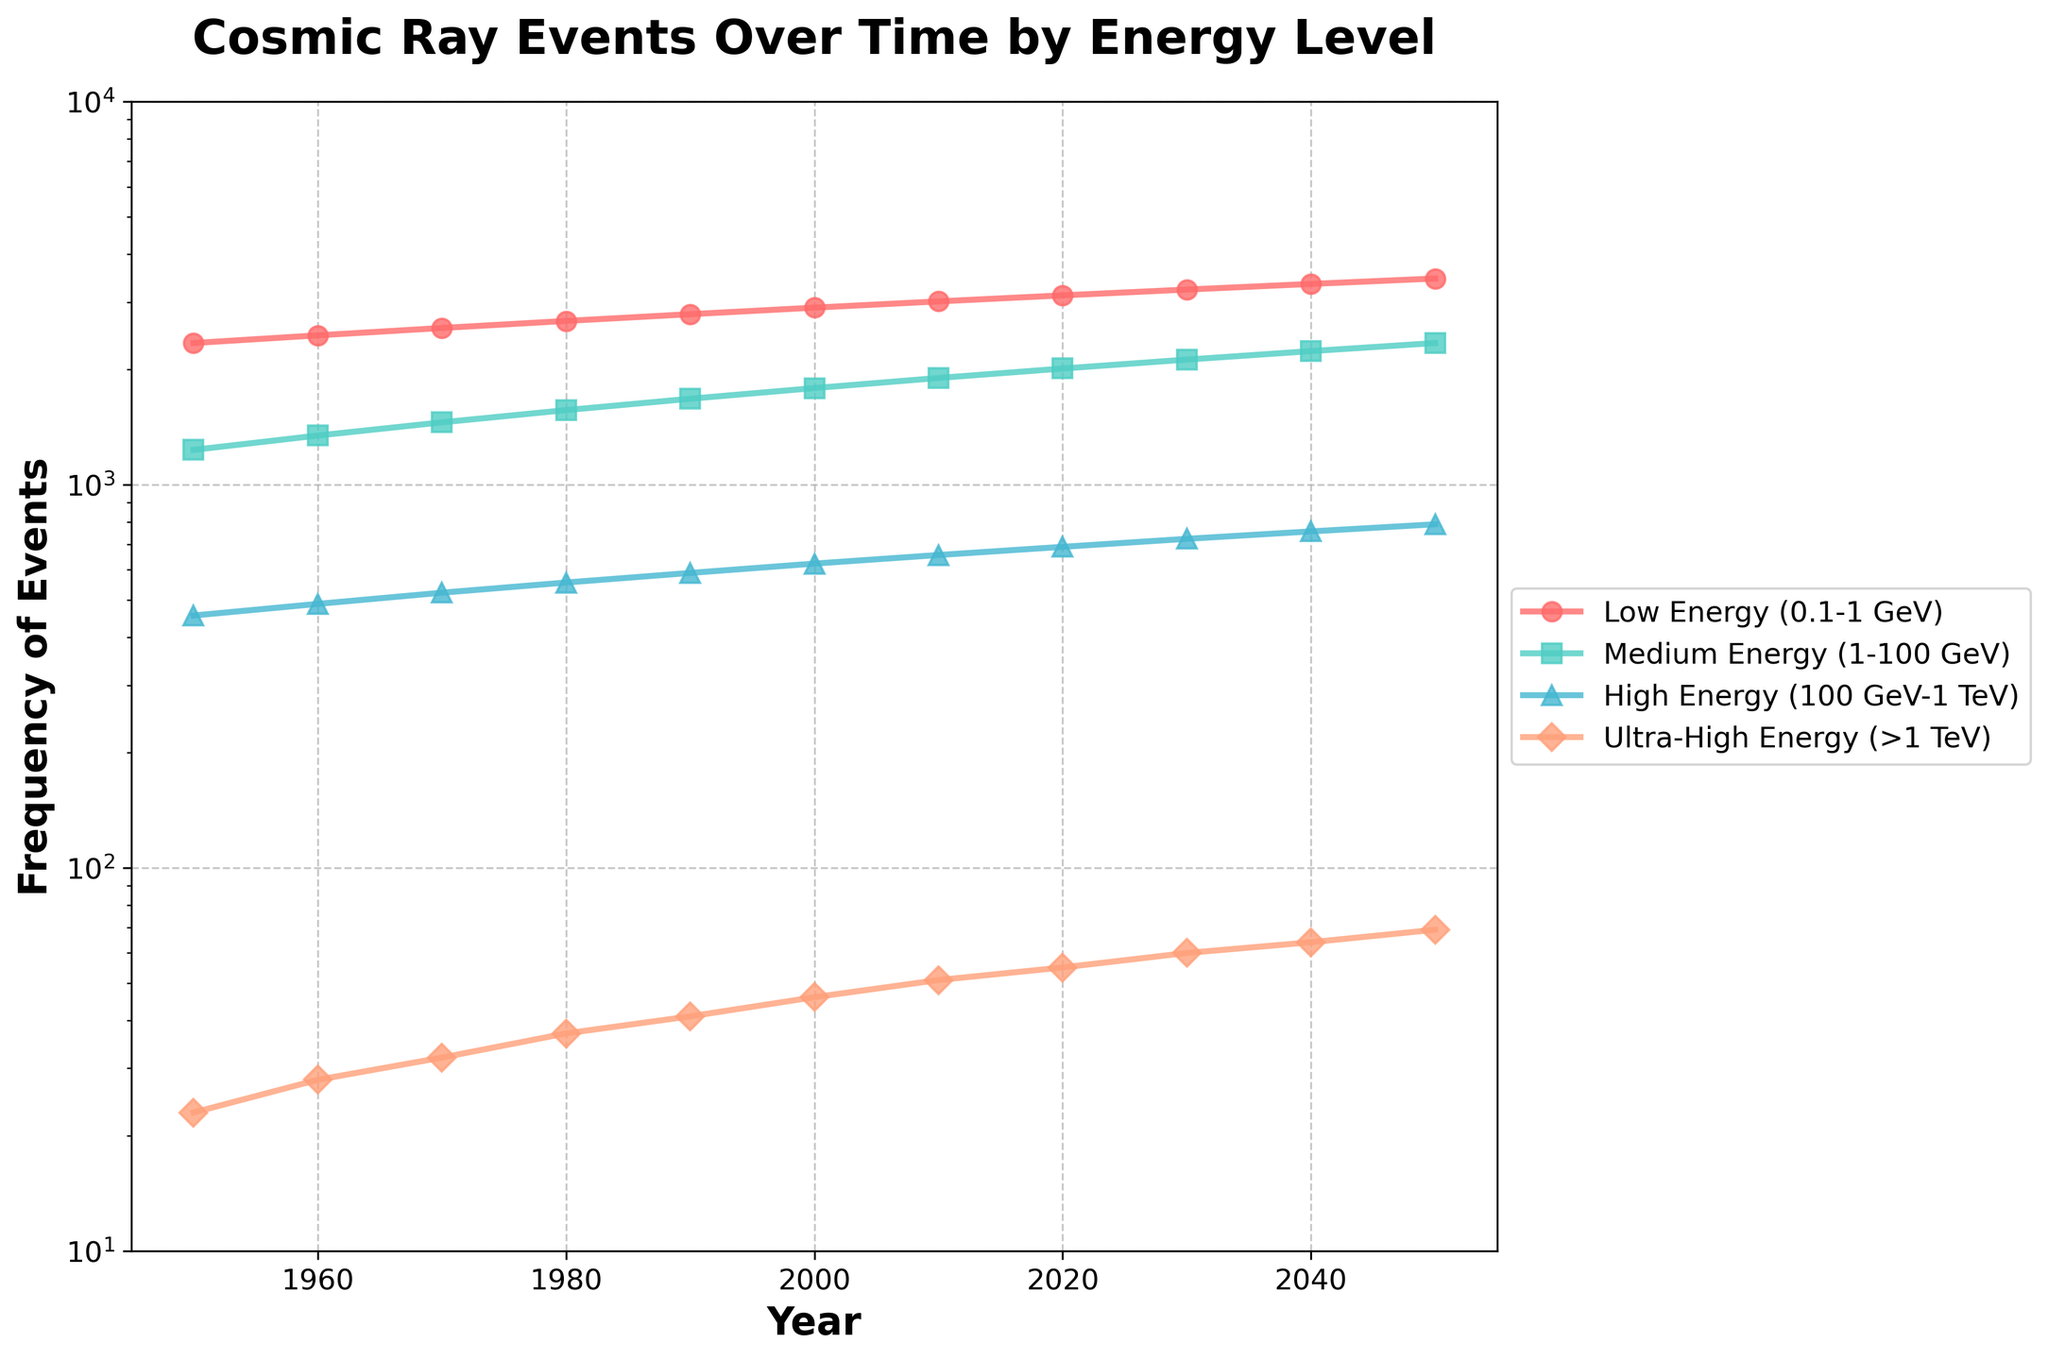What is the overall trend of Ultra-High Energy (>1 TeV) events from 1950 to 2050? To identify the trend, observe the line corresponding to Ultra-High Energy events. From 1950 to 2050, the frequency of events increases from 23 to 69, indicating an upward trend.
Answer: Upward trend In what year did Low Energy (0.1-1 GeV) events first exceed 3000? Look at the line representing Low Energy events. In 2010, the frequency of Low Energy events surpasses 3000 for the first time.
Answer: 2010 By how much did the Medium Energy (1-100 GeV) events increase from 1950 to 2050? Subtract the frequency in 1950 from the frequency in 2050 for Medium Energy events. The increase is 2345 - 1234 = 1111 events.
Answer: 1111 events Which energy category has the smallest increase in frequency from 1950 to 2050? Compare the differences in frequency for all categories between 1950 and 2050. Ultra-High Energy shows an increase from 23 to 69, which is the smallest increase (46 events).
Answer: Ultra-High Energy In which period did High Energy (100 GeV-1 TeV) events see the largest growth? Calculate the difference between consecutive decades for High Energy events and find the largest increment. The largest growth is from 2030 to 2040, with an increase from 723 to 756, which is 33 events.
Answer: 2030 to 2040 Compare the rate of increase in frequency for Low Energy and Medium Energy events from 2000 to 2020. Which one grew faster? Calculate the rate of increase for each category between 2000 and 2020: Low Energy increases from 2901 to 3123 (222 events), Medium Energy from 1789 to 2012 (223 events). Both categories have almost identical increases, but Medium Energy grows slightly faster by 1 event.
Answer: Medium Energy What is the ratio of Low Energy to Ultra-High Energy events in 2020? Divide the frequency of Low Energy events by Ultra-High Energy events in 2020: 3123 / 55 ≈ 56.78.
Answer: 56.78 What trend can be observed in the visual pattern of the markers for Medium Energy (1-100 GeV) events? Observe the markers for Medium Energy events. The markers form a near-linear upward trend throughout the given timeframe, indicating a steady and continuous increase in event frequency.
Answer: Near-linear upward trend Which decade shows the least change in frequency for Ultra-High Energy (>1 TeV) events, and by how much? Examine the increments for each decade. Between 1980 and 1990, Ultra-High Energy events increase from 37 to 41, which is the smallest change of 4 events.
Answer: 1980 to 1990, 4 events How does the frequency of events for High Energy (100 GeV-1 TeV) compare between 1960 and 2040? Compare the frequency values for High Energy events in 1960 and 2040. In 1960, the frequency is 489 and in 2040 it is 756. The frequency nearly doubles, showing a significant increment.
Answer: Nearly doubles 